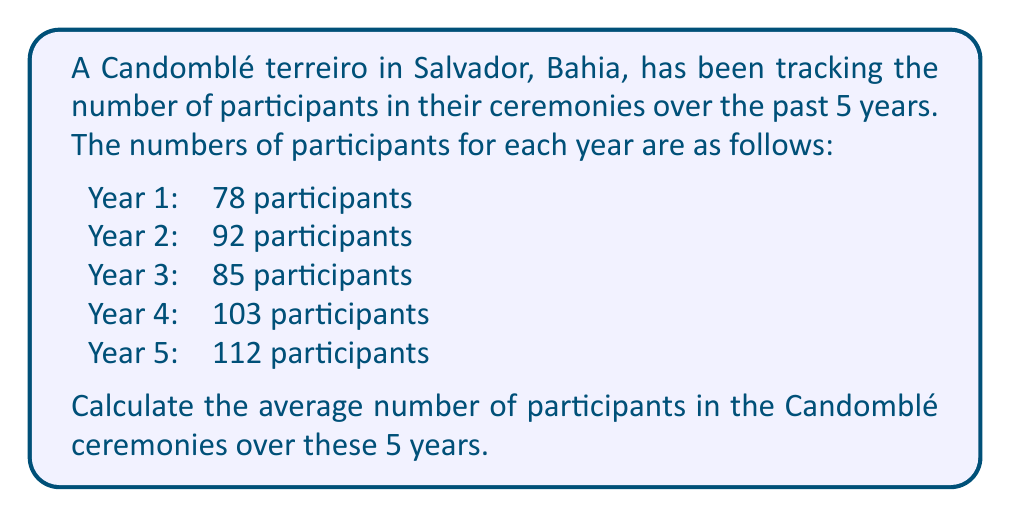Help me with this question. To find the average number of participants, we need to follow these steps:

1. Add up the total number of participants for all 5 years:
   $78 + 92 + 85 + 103 + 112 = 470$ participants

2. Divide the total by the number of years (5) to get the average:
   $$\text{Average} = \frac{\text{Sum of all values}}{\text{Number of values}}$$
   
   $$\text{Average} = \frac{470}{5} = 94$$

Therefore, the average number of participants in the Candomblé ceremonies over the 5-year period is 94 participants.
Answer: 94 participants 